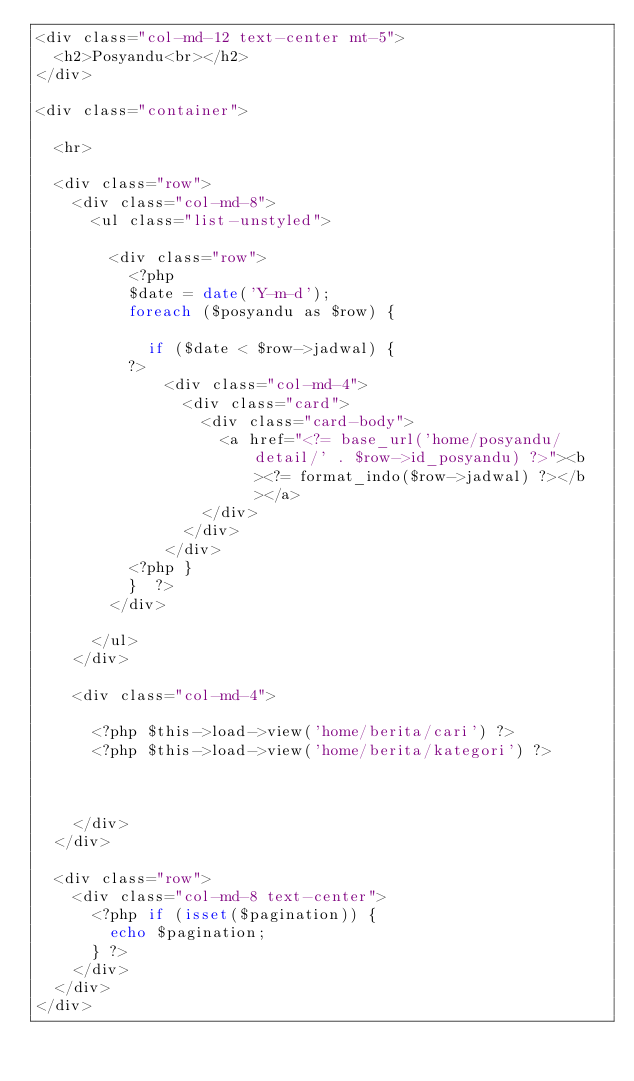Convert code to text. <code><loc_0><loc_0><loc_500><loc_500><_PHP_><div class="col-md-12 text-center mt-5">
  <h2>Posyandu<br></h2>
</div>

<div class="container">

  <hr>

  <div class="row">
    <div class="col-md-8">
      <ul class="list-unstyled">

        <div class="row">
          <?php
          $date = date('Y-m-d');
          foreach ($posyandu as $row) {

            if ($date < $row->jadwal) {
          ?>
              <div class="col-md-4">
                <div class="card">
                  <div class="card-body">
                    <a href="<?= base_url('home/posyandu/detail/' . $row->id_posyandu) ?>"><b><?= format_indo($row->jadwal) ?></b></a>
                  </div>
                </div>
              </div>
          <?php }
          }  ?>
        </div>

      </ul>
    </div>

    <div class="col-md-4">

      <?php $this->load->view('home/berita/cari') ?>
      <?php $this->load->view('home/berita/kategori') ?>



    </div>
  </div>

  <div class="row">
    <div class="col-md-8 text-center">
      <?php if (isset($pagination)) {
        echo $pagination;
      } ?>
    </div>
  </div>
</div></code> 